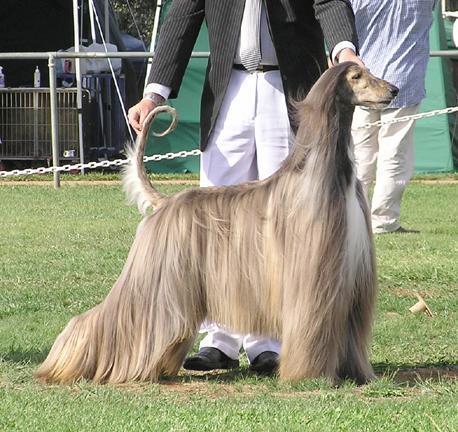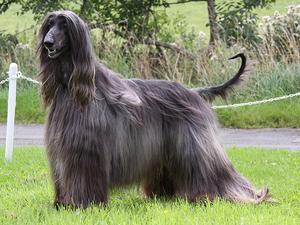The first image is the image on the left, the second image is the image on the right. Analyze the images presented: Is the assertion "A person in white slacks and a blazer stands directly behind a posed long-haired hound." valid? Answer yes or no. Yes. The first image is the image on the left, the second image is the image on the right. Evaluate the accuracy of this statement regarding the images: "There are only two dogs, and they are facing in opposite directions of each other.". Is it true? Answer yes or no. Yes. 